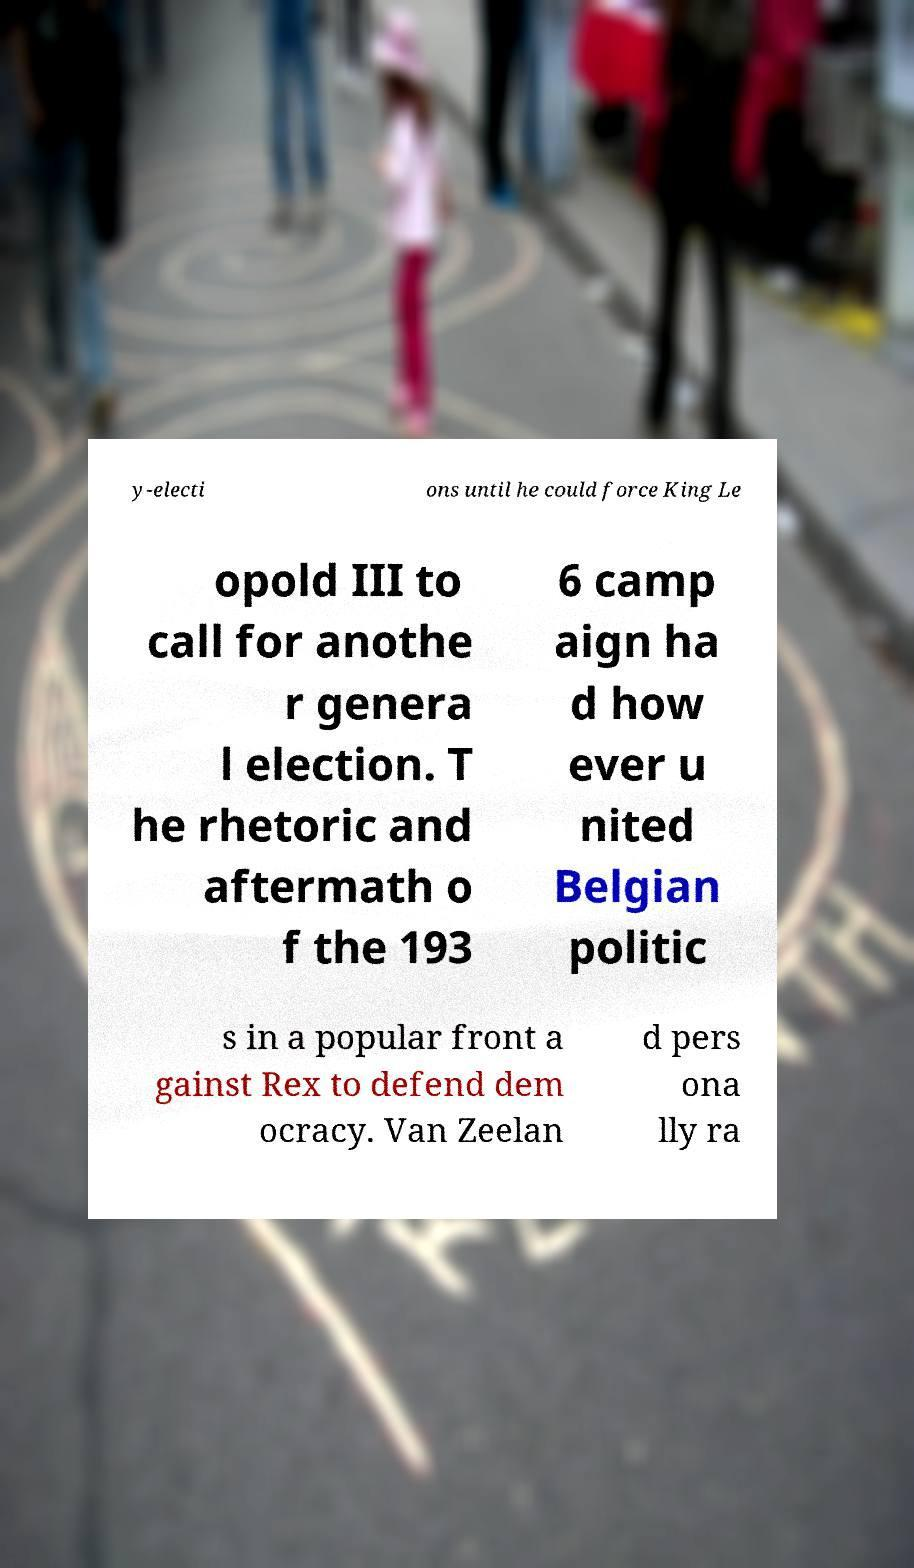What messages or text are displayed in this image? I need them in a readable, typed format. y-electi ons until he could force King Le opold III to call for anothe r genera l election. T he rhetoric and aftermath o f the 193 6 camp aign ha d how ever u nited Belgian politic s in a popular front a gainst Rex to defend dem ocracy. Van Zeelan d pers ona lly ra 